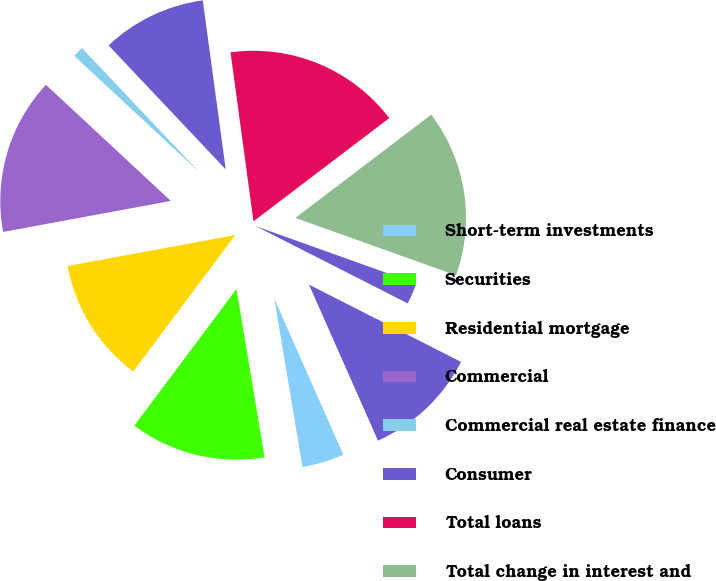<chart> <loc_0><loc_0><loc_500><loc_500><pie_chart><fcel>Short-term investments<fcel>Securities<fcel>Residential mortgage<fcel>Commercial<fcel>Commercial real estate finance<fcel>Consumer<fcel>Total loans<fcel>Total change in interest and<fcel>Savings interest-bearing<fcel>Time<nl><fcel>3.99%<fcel>12.86%<fcel>11.87%<fcel>14.83%<fcel>1.03%<fcel>9.9%<fcel>16.8%<fcel>15.81%<fcel>2.02%<fcel>10.89%<nl></chart> 